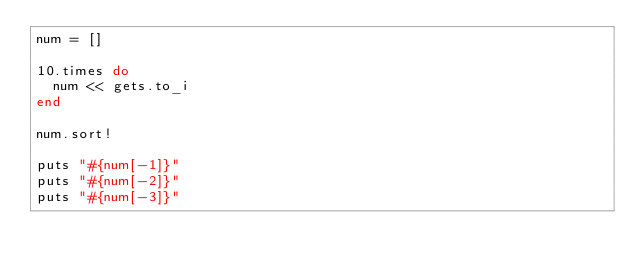Convert code to text. <code><loc_0><loc_0><loc_500><loc_500><_Ruby_>num = []

10.times do
  num << gets.to_i
end

num.sort!

puts "#{num[-1]}"
puts "#{num[-2]}"
puts "#{num[-3]}"</code> 